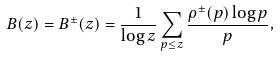<formula> <loc_0><loc_0><loc_500><loc_500>B ( z ) = B ^ { \pm } ( z ) = \frac { 1 } { \log z } \sum _ { p \leq z } \frac { \rho ^ { \pm } ( p ) \log p } { p } ,</formula> 